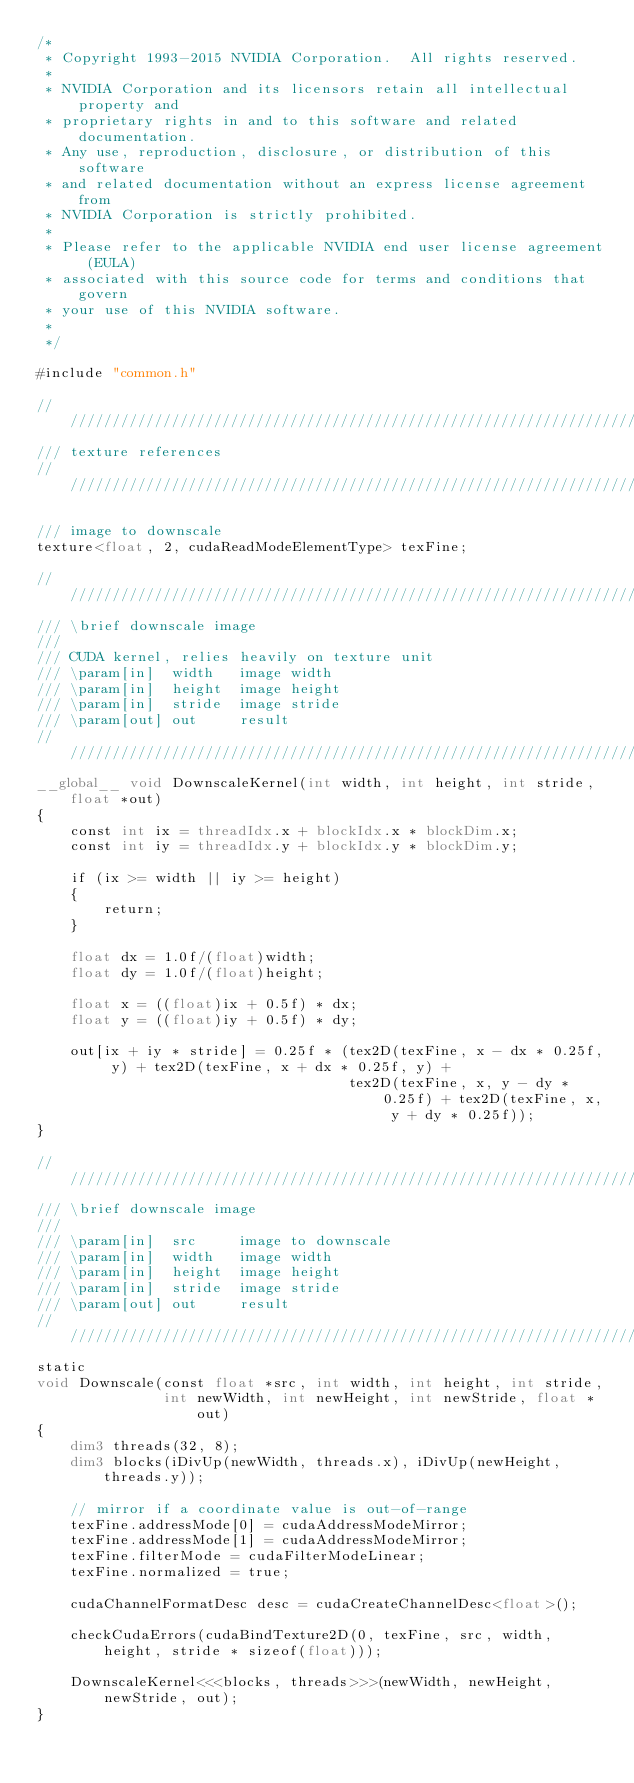<code> <loc_0><loc_0><loc_500><loc_500><_Cuda_>/*
 * Copyright 1993-2015 NVIDIA Corporation.  All rights reserved.
 *
 * NVIDIA Corporation and its licensors retain all intellectual property and
 * proprietary rights in and to this software and related documentation.
 * Any use, reproduction, disclosure, or distribution of this software
 * and related documentation without an express license agreement from
 * NVIDIA Corporation is strictly prohibited.
 *
 * Please refer to the applicable NVIDIA end user license agreement (EULA)
 * associated with this source code for terms and conditions that govern
 * your use of this NVIDIA software.
 *
 */

#include "common.h"

///////////////////////////////////////////////////////////////////////////////
/// texture references
///////////////////////////////////////////////////////////////////////////////

/// image to downscale
texture<float, 2, cudaReadModeElementType> texFine;

///////////////////////////////////////////////////////////////////////////////
/// \brief downscale image
///
/// CUDA kernel, relies heavily on texture unit
/// \param[in]  width   image width
/// \param[in]  height  image height
/// \param[in]  stride  image stride
/// \param[out] out     result
///////////////////////////////////////////////////////////////////////////////
__global__ void DownscaleKernel(int width, int height, int stride, float *out)
{
    const int ix = threadIdx.x + blockIdx.x * blockDim.x;
    const int iy = threadIdx.y + blockIdx.y * blockDim.y;

    if (ix >= width || iy >= height)
    {
        return;
    }

    float dx = 1.0f/(float)width;
    float dy = 1.0f/(float)height;

    float x = ((float)ix + 0.5f) * dx;
    float y = ((float)iy + 0.5f) * dy;

    out[ix + iy * stride] = 0.25f * (tex2D(texFine, x - dx * 0.25f, y) + tex2D(texFine, x + dx * 0.25f, y) +
                                     tex2D(texFine, x, y - dy * 0.25f) + tex2D(texFine, x, y + dy * 0.25f));
}

///////////////////////////////////////////////////////////////////////////////
/// \brief downscale image
///
/// \param[in]  src     image to downscale
/// \param[in]  width   image width
/// \param[in]  height  image height
/// \param[in]  stride  image stride
/// \param[out] out     result
///////////////////////////////////////////////////////////////////////////////
static
void Downscale(const float *src, int width, int height, int stride,
               int newWidth, int newHeight, int newStride, float *out)
{
    dim3 threads(32, 8);
    dim3 blocks(iDivUp(newWidth, threads.x), iDivUp(newHeight, threads.y));

    // mirror if a coordinate value is out-of-range
    texFine.addressMode[0] = cudaAddressModeMirror;
    texFine.addressMode[1] = cudaAddressModeMirror;
    texFine.filterMode = cudaFilterModeLinear;
    texFine.normalized = true;

    cudaChannelFormatDesc desc = cudaCreateChannelDesc<float>();

    checkCudaErrors(cudaBindTexture2D(0, texFine, src, width, height, stride * sizeof(float)));

    DownscaleKernel<<<blocks, threads>>>(newWidth, newHeight, newStride, out);
}
</code> 